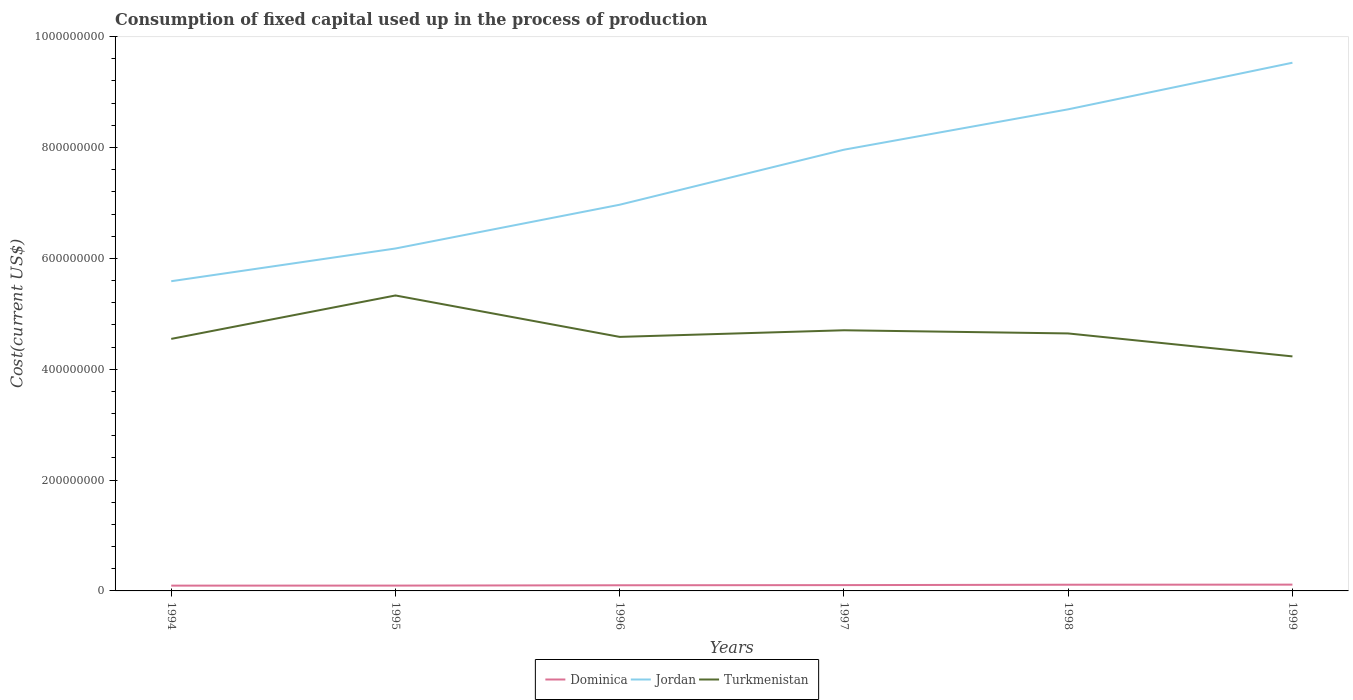How many different coloured lines are there?
Ensure brevity in your answer.  3. Is the number of lines equal to the number of legend labels?
Make the answer very short. Yes. Across all years, what is the maximum amount consumed in the process of production in Dominica?
Keep it short and to the point. 9.56e+06. In which year was the amount consumed in the process of production in Dominica maximum?
Your response must be concise. 1994. What is the total amount consumed in the process of production in Dominica in the graph?
Ensure brevity in your answer.  -4.73e+04. What is the difference between the highest and the second highest amount consumed in the process of production in Dominica?
Ensure brevity in your answer.  1.78e+06. What is the difference between the highest and the lowest amount consumed in the process of production in Turkmenistan?
Keep it short and to the point. 2. Is the amount consumed in the process of production in Jordan strictly greater than the amount consumed in the process of production in Dominica over the years?
Ensure brevity in your answer.  No. Does the graph contain any zero values?
Ensure brevity in your answer.  No. Where does the legend appear in the graph?
Offer a very short reply. Bottom center. How are the legend labels stacked?
Keep it short and to the point. Horizontal. What is the title of the graph?
Give a very brief answer. Consumption of fixed capital used up in the process of production. What is the label or title of the X-axis?
Offer a terse response. Years. What is the label or title of the Y-axis?
Your answer should be very brief. Cost(current US$). What is the Cost(current US$) in Dominica in 1994?
Your answer should be compact. 9.56e+06. What is the Cost(current US$) in Jordan in 1994?
Provide a short and direct response. 5.59e+08. What is the Cost(current US$) in Turkmenistan in 1994?
Provide a short and direct response. 4.55e+08. What is the Cost(current US$) in Dominica in 1995?
Your response must be concise. 9.61e+06. What is the Cost(current US$) of Jordan in 1995?
Your answer should be very brief. 6.18e+08. What is the Cost(current US$) of Turkmenistan in 1995?
Ensure brevity in your answer.  5.33e+08. What is the Cost(current US$) of Dominica in 1996?
Your response must be concise. 1.02e+07. What is the Cost(current US$) of Jordan in 1996?
Keep it short and to the point. 6.97e+08. What is the Cost(current US$) of Turkmenistan in 1996?
Make the answer very short. 4.58e+08. What is the Cost(current US$) of Dominica in 1997?
Your answer should be very brief. 1.05e+07. What is the Cost(current US$) in Jordan in 1997?
Your answer should be very brief. 7.96e+08. What is the Cost(current US$) of Turkmenistan in 1997?
Give a very brief answer. 4.70e+08. What is the Cost(current US$) of Dominica in 1998?
Ensure brevity in your answer.  1.12e+07. What is the Cost(current US$) in Jordan in 1998?
Give a very brief answer. 8.69e+08. What is the Cost(current US$) of Turkmenistan in 1998?
Give a very brief answer. 4.65e+08. What is the Cost(current US$) in Dominica in 1999?
Ensure brevity in your answer.  1.13e+07. What is the Cost(current US$) in Jordan in 1999?
Ensure brevity in your answer.  9.53e+08. What is the Cost(current US$) in Turkmenistan in 1999?
Offer a very short reply. 4.23e+08. Across all years, what is the maximum Cost(current US$) in Dominica?
Keep it short and to the point. 1.13e+07. Across all years, what is the maximum Cost(current US$) in Jordan?
Your response must be concise. 9.53e+08. Across all years, what is the maximum Cost(current US$) in Turkmenistan?
Provide a short and direct response. 5.33e+08. Across all years, what is the minimum Cost(current US$) in Dominica?
Provide a succinct answer. 9.56e+06. Across all years, what is the minimum Cost(current US$) of Jordan?
Make the answer very short. 5.59e+08. Across all years, what is the minimum Cost(current US$) in Turkmenistan?
Provide a short and direct response. 4.23e+08. What is the total Cost(current US$) in Dominica in the graph?
Ensure brevity in your answer.  6.24e+07. What is the total Cost(current US$) of Jordan in the graph?
Offer a terse response. 4.49e+09. What is the total Cost(current US$) of Turkmenistan in the graph?
Give a very brief answer. 2.80e+09. What is the difference between the Cost(current US$) of Dominica in 1994 and that in 1995?
Offer a terse response. -4.73e+04. What is the difference between the Cost(current US$) in Jordan in 1994 and that in 1995?
Make the answer very short. -5.90e+07. What is the difference between the Cost(current US$) in Turkmenistan in 1994 and that in 1995?
Offer a terse response. -7.83e+07. What is the difference between the Cost(current US$) of Dominica in 1994 and that in 1996?
Your response must be concise. -6.28e+05. What is the difference between the Cost(current US$) in Jordan in 1994 and that in 1996?
Ensure brevity in your answer.  -1.38e+08. What is the difference between the Cost(current US$) of Turkmenistan in 1994 and that in 1996?
Provide a short and direct response. -3.59e+06. What is the difference between the Cost(current US$) of Dominica in 1994 and that in 1997?
Keep it short and to the point. -9.34e+05. What is the difference between the Cost(current US$) in Jordan in 1994 and that in 1997?
Your response must be concise. -2.37e+08. What is the difference between the Cost(current US$) in Turkmenistan in 1994 and that in 1997?
Your answer should be very brief. -1.55e+07. What is the difference between the Cost(current US$) in Dominica in 1994 and that in 1998?
Provide a succinct answer. -1.63e+06. What is the difference between the Cost(current US$) of Jordan in 1994 and that in 1998?
Your response must be concise. -3.10e+08. What is the difference between the Cost(current US$) of Turkmenistan in 1994 and that in 1998?
Your answer should be very brief. -9.82e+06. What is the difference between the Cost(current US$) of Dominica in 1994 and that in 1999?
Give a very brief answer. -1.78e+06. What is the difference between the Cost(current US$) of Jordan in 1994 and that in 1999?
Your response must be concise. -3.94e+08. What is the difference between the Cost(current US$) of Turkmenistan in 1994 and that in 1999?
Give a very brief answer. 3.16e+07. What is the difference between the Cost(current US$) of Dominica in 1995 and that in 1996?
Make the answer very short. -5.81e+05. What is the difference between the Cost(current US$) of Jordan in 1995 and that in 1996?
Keep it short and to the point. -7.90e+07. What is the difference between the Cost(current US$) of Turkmenistan in 1995 and that in 1996?
Provide a short and direct response. 7.47e+07. What is the difference between the Cost(current US$) of Dominica in 1995 and that in 1997?
Your answer should be compact. -8.87e+05. What is the difference between the Cost(current US$) in Jordan in 1995 and that in 1997?
Your answer should be very brief. -1.78e+08. What is the difference between the Cost(current US$) in Turkmenistan in 1995 and that in 1997?
Provide a short and direct response. 6.28e+07. What is the difference between the Cost(current US$) of Dominica in 1995 and that in 1998?
Ensure brevity in your answer.  -1.58e+06. What is the difference between the Cost(current US$) in Jordan in 1995 and that in 1998?
Provide a short and direct response. -2.51e+08. What is the difference between the Cost(current US$) of Turkmenistan in 1995 and that in 1998?
Make the answer very short. 6.85e+07. What is the difference between the Cost(current US$) in Dominica in 1995 and that in 1999?
Ensure brevity in your answer.  -1.74e+06. What is the difference between the Cost(current US$) of Jordan in 1995 and that in 1999?
Provide a succinct answer. -3.35e+08. What is the difference between the Cost(current US$) of Turkmenistan in 1995 and that in 1999?
Offer a terse response. 1.10e+08. What is the difference between the Cost(current US$) of Dominica in 1996 and that in 1997?
Give a very brief answer. -3.06e+05. What is the difference between the Cost(current US$) of Jordan in 1996 and that in 1997?
Offer a very short reply. -9.93e+07. What is the difference between the Cost(current US$) of Turkmenistan in 1996 and that in 1997?
Make the answer very short. -1.20e+07. What is the difference between the Cost(current US$) in Dominica in 1996 and that in 1998?
Provide a short and direct response. -1.00e+06. What is the difference between the Cost(current US$) in Jordan in 1996 and that in 1998?
Your answer should be very brief. -1.72e+08. What is the difference between the Cost(current US$) in Turkmenistan in 1996 and that in 1998?
Your answer should be very brief. -6.23e+06. What is the difference between the Cost(current US$) in Dominica in 1996 and that in 1999?
Your answer should be compact. -1.16e+06. What is the difference between the Cost(current US$) in Jordan in 1996 and that in 1999?
Offer a very short reply. -2.56e+08. What is the difference between the Cost(current US$) of Turkmenistan in 1996 and that in 1999?
Make the answer very short. 3.52e+07. What is the difference between the Cost(current US$) of Dominica in 1997 and that in 1998?
Provide a succinct answer. -6.97e+05. What is the difference between the Cost(current US$) in Jordan in 1997 and that in 1998?
Your answer should be very brief. -7.29e+07. What is the difference between the Cost(current US$) in Turkmenistan in 1997 and that in 1998?
Your answer should be compact. 5.72e+06. What is the difference between the Cost(current US$) of Dominica in 1997 and that in 1999?
Your answer should be compact. -8.49e+05. What is the difference between the Cost(current US$) in Jordan in 1997 and that in 1999?
Provide a succinct answer. -1.57e+08. What is the difference between the Cost(current US$) in Turkmenistan in 1997 and that in 1999?
Give a very brief answer. 4.71e+07. What is the difference between the Cost(current US$) of Dominica in 1998 and that in 1999?
Offer a very short reply. -1.53e+05. What is the difference between the Cost(current US$) of Jordan in 1998 and that in 1999?
Your answer should be very brief. -8.41e+07. What is the difference between the Cost(current US$) in Turkmenistan in 1998 and that in 1999?
Offer a very short reply. 4.14e+07. What is the difference between the Cost(current US$) in Dominica in 1994 and the Cost(current US$) in Jordan in 1995?
Offer a terse response. -6.08e+08. What is the difference between the Cost(current US$) in Dominica in 1994 and the Cost(current US$) in Turkmenistan in 1995?
Keep it short and to the point. -5.23e+08. What is the difference between the Cost(current US$) of Jordan in 1994 and the Cost(current US$) of Turkmenistan in 1995?
Give a very brief answer. 2.57e+07. What is the difference between the Cost(current US$) of Dominica in 1994 and the Cost(current US$) of Jordan in 1996?
Keep it short and to the point. -6.87e+08. What is the difference between the Cost(current US$) in Dominica in 1994 and the Cost(current US$) in Turkmenistan in 1996?
Give a very brief answer. -4.49e+08. What is the difference between the Cost(current US$) of Jordan in 1994 and the Cost(current US$) of Turkmenistan in 1996?
Your response must be concise. 1.00e+08. What is the difference between the Cost(current US$) of Dominica in 1994 and the Cost(current US$) of Jordan in 1997?
Your answer should be compact. -7.86e+08. What is the difference between the Cost(current US$) in Dominica in 1994 and the Cost(current US$) in Turkmenistan in 1997?
Your answer should be very brief. -4.61e+08. What is the difference between the Cost(current US$) of Jordan in 1994 and the Cost(current US$) of Turkmenistan in 1997?
Keep it short and to the point. 8.85e+07. What is the difference between the Cost(current US$) in Dominica in 1994 and the Cost(current US$) in Jordan in 1998?
Provide a short and direct response. -8.59e+08. What is the difference between the Cost(current US$) of Dominica in 1994 and the Cost(current US$) of Turkmenistan in 1998?
Make the answer very short. -4.55e+08. What is the difference between the Cost(current US$) of Jordan in 1994 and the Cost(current US$) of Turkmenistan in 1998?
Provide a short and direct response. 9.42e+07. What is the difference between the Cost(current US$) in Dominica in 1994 and the Cost(current US$) in Jordan in 1999?
Offer a very short reply. -9.43e+08. What is the difference between the Cost(current US$) in Dominica in 1994 and the Cost(current US$) in Turkmenistan in 1999?
Your answer should be compact. -4.14e+08. What is the difference between the Cost(current US$) in Jordan in 1994 and the Cost(current US$) in Turkmenistan in 1999?
Give a very brief answer. 1.36e+08. What is the difference between the Cost(current US$) of Dominica in 1995 and the Cost(current US$) of Jordan in 1996?
Keep it short and to the point. -6.87e+08. What is the difference between the Cost(current US$) of Dominica in 1995 and the Cost(current US$) of Turkmenistan in 1996?
Provide a short and direct response. -4.49e+08. What is the difference between the Cost(current US$) of Jordan in 1995 and the Cost(current US$) of Turkmenistan in 1996?
Ensure brevity in your answer.  1.60e+08. What is the difference between the Cost(current US$) of Dominica in 1995 and the Cost(current US$) of Jordan in 1997?
Give a very brief answer. -7.86e+08. What is the difference between the Cost(current US$) of Dominica in 1995 and the Cost(current US$) of Turkmenistan in 1997?
Provide a short and direct response. -4.61e+08. What is the difference between the Cost(current US$) of Jordan in 1995 and the Cost(current US$) of Turkmenistan in 1997?
Make the answer very short. 1.48e+08. What is the difference between the Cost(current US$) of Dominica in 1995 and the Cost(current US$) of Jordan in 1998?
Provide a short and direct response. -8.59e+08. What is the difference between the Cost(current US$) in Dominica in 1995 and the Cost(current US$) in Turkmenistan in 1998?
Give a very brief answer. -4.55e+08. What is the difference between the Cost(current US$) in Jordan in 1995 and the Cost(current US$) in Turkmenistan in 1998?
Keep it short and to the point. 1.53e+08. What is the difference between the Cost(current US$) in Dominica in 1995 and the Cost(current US$) in Jordan in 1999?
Your response must be concise. -9.43e+08. What is the difference between the Cost(current US$) of Dominica in 1995 and the Cost(current US$) of Turkmenistan in 1999?
Make the answer very short. -4.14e+08. What is the difference between the Cost(current US$) of Jordan in 1995 and the Cost(current US$) of Turkmenistan in 1999?
Keep it short and to the point. 1.95e+08. What is the difference between the Cost(current US$) of Dominica in 1996 and the Cost(current US$) of Jordan in 1997?
Give a very brief answer. -7.86e+08. What is the difference between the Cost(current US$) of Dominica in 1996 and the Cost(current US$) of Turkmenistan in 1997?
Provide a succinct answer. -4.60e+08. What is the difference between the Cost(current US$) of Jordan in 1996 and the Cost(current US$) of Turkmenistan in 1997?
Offer a very short reply. 2.27e+08. What is the difference between the Cost(current US$) in Dominica in 1996 and the Cost(current US$) in Jordan in 1998?
Keep it short and to the point. -8.59e+08. What is the difference between the Cost(current US$) of Dominica in 1996 and the Cost(current US$) of Turkmenistan in 1998?
Offer a terse response. -4.54e+08. What is the difference between the Cost(current US$) of Jordan in 1996 and the Cost(current US$) of Turkmenistan in 1998?
Keep it short and to the point. 2.32e+08. What is the difference between the Cost(current US$) in Dominica in 1996 and the Cost(current US$) in Jordan in 1999?
Your answer should be compact. -9.43e+08. What is the difference between the Cost(current US$) in Dominica in 1996 and the Cost(current US$) in Turkmenistan in 1999?
Offer a very short reply. -4.13e+08. What is the difference between the Cost(current US$) in Jordan in 1996 and the Cost(current US$) in Turkmenistan in 1999?
Your response must be concise. 2.74e+08. What is the difference between the Cost(current US$) of Dominica in 1997 and the Cost(current US$) of Jordan in 1998?
Offer a terse response. -8.58e+08. What is the difference between the Cost(current US$) of Dominica in 1997 and the Cost(current US$) of Turkmenistan in 1998?
Make the answer very short. -4.54e+08. What is the difference between the Cost(current US$) in Jordan in 1997 and the Cost(current US$) in Turkmenistan in 1998?
Your response must be concise. 3.31e+08. What is the difference between the Cost(current US$) of Dominica in 1997 and the Cost(current US$) of Jordan in 1999?
Make the answer very short. -9.42e+08. What is the difference between the Cost(current US$) of Dominica in 1997 and the Cost(current US$) of Turkmenistan in 1999?
Your answer should be compact. -4.13e+08. What is the difference between the Cost(current US$) in Jordan in 1997 and the Cost(current US$) in Turkmenistan in 1999?
Provide a short and direct response. 3.73e+08. What is the difference between the Cost(current US$) of Dominica in 1998 and the Cost(current US$) of Jordan in 1999?
Provide a succinct answer. -9.42e+08. What is the difference between the Cost(current US$) of Dominica in 1998 and the Cost(current US$) of Turkmenistan in 1999?
Make the answer very short. -4.12e+08. What is the difference between the Cost(current US$) of Jordan in 1998 and the Cost(current US$) of Turkmenistan in 1999?
Keep it short and to the point. 4.46e+08. What is the average Cost(current US$) of Dominica per year?
Offer a terse response. 1.04e+07. What is the average Cost(current US$) of Jordan per year?
Your answer should be very brief. 7.49e+08. What is the average Cost(current US$) in Turkmenistan per year?
Your answer should be very brief. 4.67e+08. In the year 1994, what is the difference between the Cost(current US$) in Dominica and Cost(current US$) in Jordan?
Provide a short and direct response. -5.49e+08. In the year 1994, what is the difference between the Cost(current US$) in Dominica and Cost(current US$) in Turkmenistan?
Your answer should be compact. -4.45e+08. In the year 1994, what is the difference between the Cost(current US$) of Jordan and Cost(current US$) of Turkmenistan?
Provide a succinct answer. 1.04e+08. In the year 1995, what is the difference between the Cost(current US$) in Dominica and Cost(current US$) in Jordan?
Your answer should be very brief. -6.08e+08. In the year 1995, what is the difference between the Cost(current US$) of Dominica and Cost(current US$) of Turkmenistan?
Provide a succinct answer. -5.23e+08. In the year 1995, what is the difference between the Cost(current US$) of Jordan and Cost(current US$) of Turkmenistan?
Your answer should be compact. 8.48e+07. In the year 1996, what is the difference between the Cost(current US$) of Dominica and Cost(current US$) of Jordan?
Offer a terse response. -6.87e+08. In the year 1996, what is the difference between the Cost(current US$) of Dominica and Cost(current US$) of Turkmenistan?
Your answer should be compact. -4.48e+08. In the year 1996, what is the difference between the Cost(current US$) of Jordan and Cost(current US$) of Turkmenistan?
Your answer should be very brief. 2.38e+08. In the year 1997, what is the difference between the Cost(current US$) in Dominica and Cost(current US$) in Jordan?
Make the answer very short. -7.86e+08. In the year 1997, what is the difference between the Cost(current US$) in Dominica and Cost(current US$) in Turkmenistan?
Your answer should be very brief. -4.60e+08. In the year 1997, what is the difference between the Cost(current US$) of Jordan and Cost(current US$) of Turkmenistan?
Provide a succinct answer. 3.26e+08. In the year 1998, what is the difference between the Cost(current US$) in Dominica and Cost(current US$) in Jordan?
Keep it short and to the point. -8.58e+08. In the year 1998, what is the difference between the Cost(current US$) in Dominica and Cost(current US$) in Turkmenistan?
Your answer should be compact. -4.53e+08. In the year 1998, what is the difference between the Cost(current US$) of Jordan and Cost(current US$) of Turkmenistan?
Your answer should be very brief. 4.04e+08. In the year 1999, what is the difference between the Cost(current US$) in Dominica and Cost(current US$) in Jordan?
Offer a very short reply. -9.42e+08. In the year 1999, what is the difference between the Cost(current US$) of Dominica and Cost(current US$) of Turkmenistan?
Your answer should be compact. -4.12e+08. In the year 1999, what is the difference between the Cost(current US$) of Jordan and Cost(current US$) of Turkmenistan?
Your answer should be compact. 5.30e+08. What is the ratio of the Cost(current US$) in Jordan in 1994 to that in 1995?
Your answer should be very brief. 0.9. What is the ratio of the Cost(current US$) of Turkmenistan in 1994 to that in 1995?
Give a very brief answer. 0.85. What is the ratio of the Cost(current US$) of Dominica in 1994 to that in 1996?
Your answer should be compact. 0.94. What is the ratio of the Cost(current US$) in Jordan in 1994 to that in 1996?
Your answer should be compact. 0.8. What is the ratio of the Cost(current US$) in Turkmenistan in 1994 to that in 1996?
Offer a very short reply. 0.99. What is the ratio of the Cost(current US$) in Dominica in 1994 to that in 1997?
Give a very brief answer. 0.91. What is the ratio of the Cost(current US$) of Jordan in 1994 to that in 1997?
Give a very brief answer. 0.7. What is the ratio of the Cost(current US$) in Dominica in 1994 to that in 1998?
Provide a short and direct response. 0.85. What is the ratio of the Cost(current US$) of Jordan in 1994 to that in 1998?
Your response must be concise. 0.64. What is the ratio of the Cost(current US$) of Turkmenistan in 1994 to that in 1998?
Your response must be concise. 0.98. What is the ratio of the Cost(current US$) of Dominica in 1994 to that in 1999?
Keep it short and to the point. 0.84. What is the ratio of the Cost(current US$) in Jordan in 1994 to that in 1999?
Provide a short and direct response. 0.59. What is the ratio of the Cost(current US$) of Turkmenistan in 1994 to that in 1999?
Provide a succinct answer. 1.07. What is the ratio of the Cost(current US$) in Dominica in 1995 to that in 1996?
Give a very brief answer. 0.94. What is the ratio of the Cost(current US$) in Jordan in 1995 to that in 1996?
Provide a short and direct response. 0.89. What is the ratio of the Cost(current US$) in Turkmenistan in 1995 to that in 1996?
Give a very brief answer. 1.16. What is the ratio of the Cost(current US$) of Dominica in 1995 to that in 1997?
Your answer should be compact. 0.92. What is the ratio of the Cost(current US$) of Jordan in 1995 to that in 1997?
Make the answer very short. 0.78. What is the ratio of the Cost(current US$) in Turkmenistan in 1995 to that in 1997?
Offer a very short reply. 1.13. What is the ratio of the Cost(current US$) in Dominica in 1995 to that in 1998?
Provide a succinct answer. 0.86. What is the ratio of the Cost(current US$) of Jordan in 1995 to that in 1998?
Make the answer very short. 0.71. What is the ratio of the Cost(current US$) of Turkmenistan in 1995 to that in 1998?
Keep it short and to the point. 1.15. What is the ratio of the Cost(current US$) of Dominica in 1995 to that in 1999?
Give a very brief answer. 0.85. What is the ratio of the Cost(current US$) in Jordan in 1995 to that in 1999?
Keep it short and to the point. 0.65. What is the ratio of the Cost(current US$) of Turkmenistan in 1995 to that in 1999?
Provide a succinct answer. 1.26. What is the ratio of the Cost(current US$) of Dominica in 1996 to that in 1997?
Ensure brevity in your answer.  0.97. What is the ratio of the Cost(current US$) of Jordan in 1996 to that in 1997?
Offer a very short reply. 0.88. What is the ratio of the Cost(current US$) in Turkmenistan in 1996 to that in 1997?
Offer a very short reply. 0.97. What is the ratio of the Cost(current US$) of Dominica in 1996 to that in 1998?
Provide a succinct answer. 0.91. What is the ratio of the Cost(current US$) of Jordan in 1996 to that in 1998?
Give a very brief answer. 0.8. What is the ratio of the Cost(current US$) in Turkmenistan in 1996 to that in 1998?
Your answer should be very brief. 0.99. What is the ratio of the Cost(current US$) in Dominica in 1996 to that in 1999?
Make the answer very short. 0.9. What is the ratio of the Cost(current US$) in Jordan in 1996 to that in 1999?
Ensure brevity in your answer.  0.73. What is the ratio of the Cost(current US$) of Turkmenistan in 1996 to that in 1999?
Give a very brief answer. 1.08. What is the ratio of the Cost(current US$) in Dominica in 1997 to that in 1998?
Your response must be concise. 0.94. What is the ratio of the Cost(current US$) of Jordan in 1997 to that in 1998?
Keep it short and to the point. 0.92. What is the ratio of the Cost(current US$) in Turkmenistan in 1997 to that in 1998?
Provide a short and direct response. 1.01. What is the ratio of the Cost(current US$) of Dominica in 1997 to that in 1999?
Offer a terse response. 0.93. What is the ratio of the Cost(current US$) of Jordan in 1997 to that in 1999?
Offer a terse response. 0.84. What is the ratio of the Cost(current US$) of Turkmenistan in 1997 to that in 1999?
Give a very brief answer. 1.11. What is the ratio of the Cost(current US$) of Dominica in 1998 to that in 1999?
Ensure brevity in your answer.  0.99. What is the ratio of the Cost(current US$) of Jordan in 1998 to that in 1999?
Your response must be concise. 0.91. What is the ratio of the Cost(current US$) in Turkmenistan in 1998 to that in 1999?
Give a very brief answer. 1.1. What is the difference between the highest and the second highest Cost(current US$) of Dominica?
Make the answer very short. 1.53e+05. What is the difference between the highest and the second highest Cost(current US$) in Jordan?
Your answer should be compact. 8.41e+07. What is the difference between the highest and the second highest Cost(current US$) in Turkmenistan?
Your response must be concise. 6.28e+07. What is the difference between the highest and the lowest Cost(current US$) of Dominica?
Ensure brevity in your answer.  1.78e+06. What is the difference between the highest and the lowest Cost(current US$) of Jordan?
Your response must be concise. 3.94e+08. What is the difference between the highest and the lowest Cost(current US$) in Turkmenistan?
Offer a terse response. 1.10e+08. 